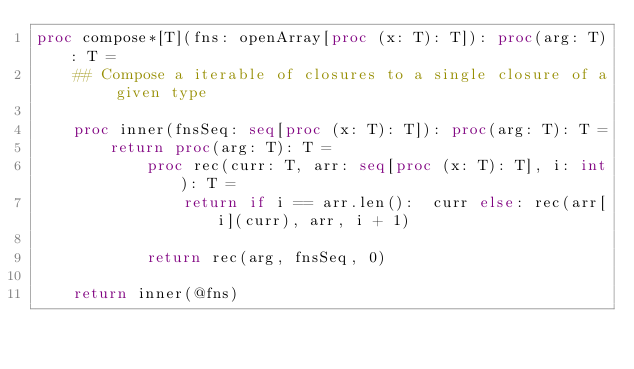Convert code to text. <code><loc_0><loc_0><loc_500><loc_500><_Nim_>proc compose*[T](fns: openArray[proc (x: T): T]): proc(arg: T): T =
    ## Compose a iterable of closures to a single closure of a given type

    proc inner(fnsSeq: seq[proc (x: T): T]): proc(arg: T): T =
        return proc(arg: T): T =
            proc rec(curr: T, arr: seq[proc (x: T): T], i: int): T =
                return if i == arr.len():  curr else: rec(arr[i](curr), arr, i + 1)

            return rec(arg, fnsSeq, 0)

    return inner(@fns)
</code> 